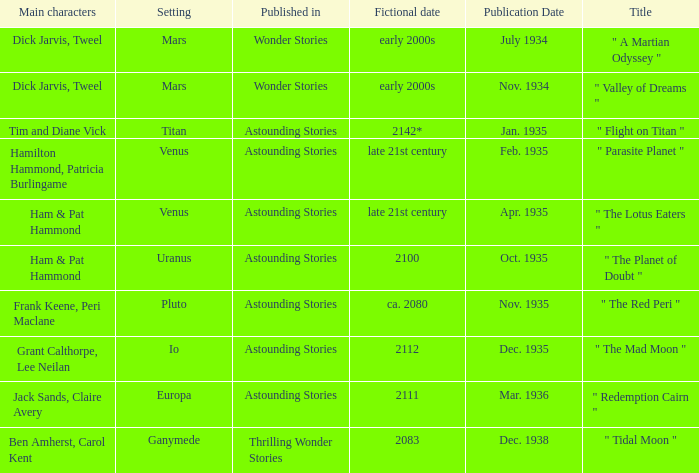Name the publication date when the fictional date is 2112 Dec. 1935. 